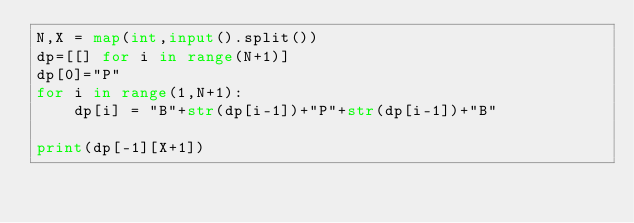Convert code to text. <code><loc_0><loc_0><loc_500><loc_500><_Python_>N,X = map(int,input().split())
dp=[[] for i in range(N+1)]
dp[0]="P"
for i in range(1,N+1):
    dp[i] = "B"+str(dp[i-1])+"P"+str(dp[i-1])+"B"

print(dp[-1][X+1])</code> 